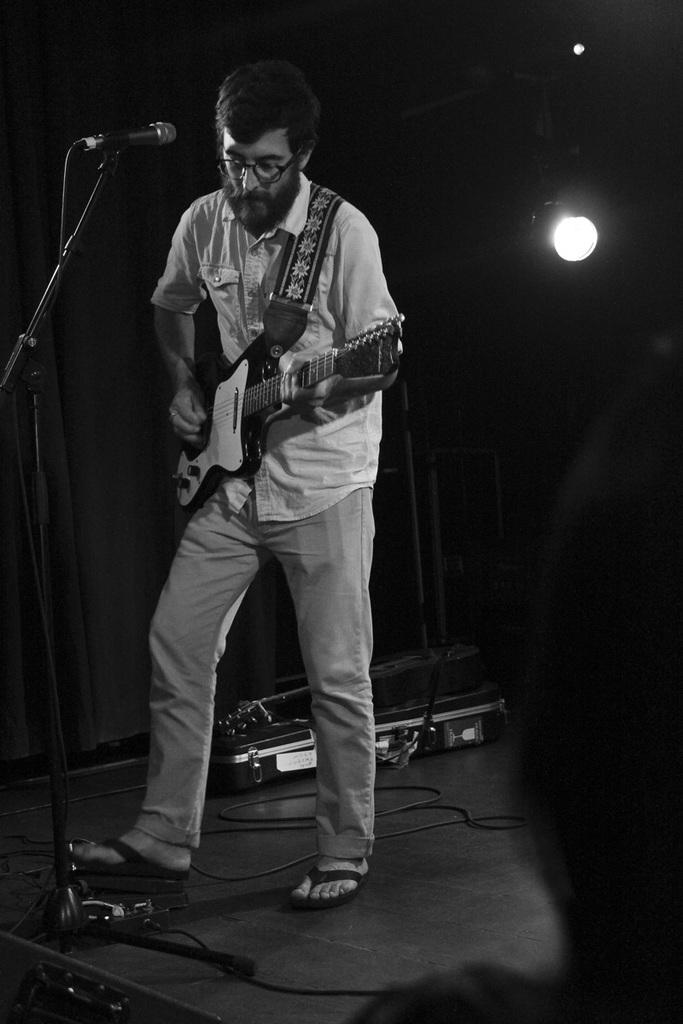Could you give a brief overview of what you see in this image? In the center we can see the person he is playing guitar. In front of him there is a microphone. 